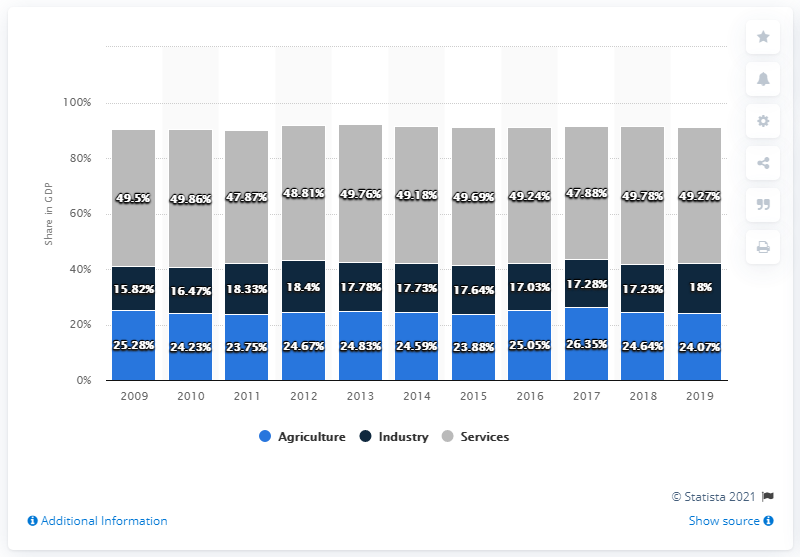Highlight a few significant elements in this photo. The share of services in GDP in 2019 was 49.27%. The share of agriculture in GDP during the period of 2010 to 2011 was 23.99%. 